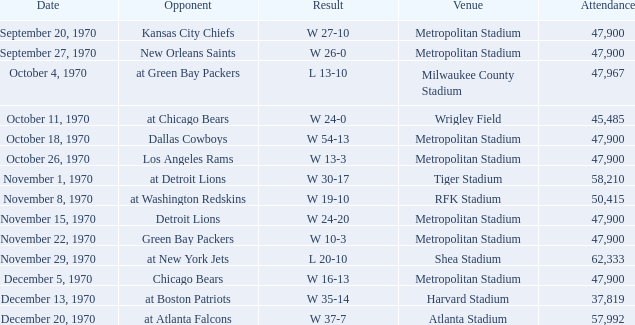Write the full table. {'header': ['Date', 'Opponent', 'Result', 'Venue', 'Attendance'], 'rows': [['September 20, 1970', 'Kansas City Chiefs', 'W 27-10', 'Metropolitan Stadium', '47,900'], ['September 27, 1970', 'New Orleans Saints', 'W 26-0', 'Metropolitan Stadium', '47,900'], ['October 4, 1970', 'at Green Bay Packers', 'L 13-10', 'Milwaukee County Stadium', '47,967'], ['October 11, 1970', 'at Chicago Bears', 'W 24-0', 'Wrigley Field', '45,485'], ['October 18, 1970', 'Dallas Cowboys', 'W 54-13', 'Metropolitan Stadium', '47,900'], ['October 26, 1970', 'Los Angeles Rams', 'W 13-3', 'Metropolitan Stadium', '47,900'], ['November 1, 1970', 'at Detroit Lions', 'W 30-17', 'Tiger Stadium', '58,210'], ['November 8, 1970', 'at Washington Redskins', 'W 19-10', 'RFK Stadium', '50,415'], ['November 15, 1970', 'Detroit Lions', 'W 24-20', 'Metropolitan Stadium', '47,900'], ['November 22, 1970', 'Green Bay Packers', 'W 10-3', 'Metropolitan Stadium', '47,900'], ['November 29, 1970', 'at New York Jets', 'L 20-10', 'Shea Stadium', '62,333'], ['December 5, 1970', 'Chicago Bears', 'W 16-13', 'Metropolitan Stadium', '47,900'], ['December 13, 1970', 'at Boston Patriots', 'W 35-14', 'Harvard Stadium', '37,819'], ['December 20, 1970', 'at Atlanta Falcons', 'W 37-7', 'Atlanta Stadium', '57,992']]} How many people attended the game with a result of w 16-13 and a week earlier than 12? None. 